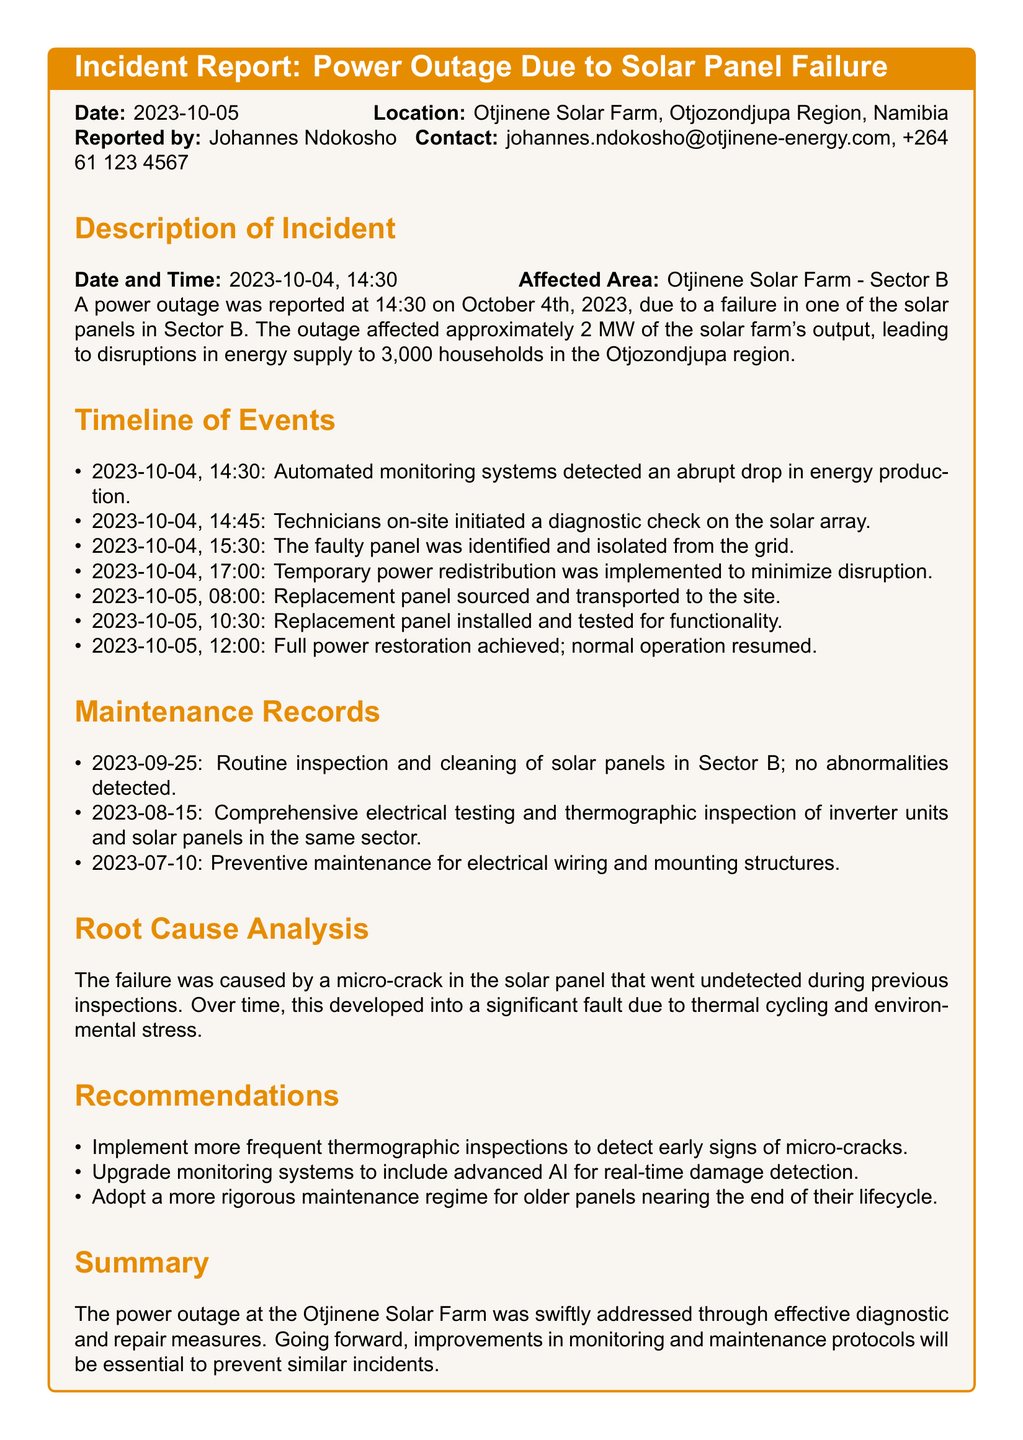what was the date of the incident? The incident occurred on October 4, 2023, as stated in the report.
Answer: October 4, 2023 who reported the incident? The incident report mentions Johannes Ndokosho as the person who reported it.
Answer: Johannes Ndokosho how much power was affected by the outage? The document states that approximately 2 MW of the solar farm's output was affected.
Answer: 2 MW what was the root cause of the solar panel failure? The report describes the root cause as a micro-crack in the solar panel that went undetected.
Answer: micro-crack when was the faulty panel identified? The timeline indicates that the faulty panel was identified on October 4, 2023, at 15:30.
Answer: October 4, 2023, 15:30 what recommendation is given for inspection frequency? The document suggests implementing more frequent thermographic inspections to detect micro-cracks.
Answer: more frequent thermographic inspections how long did it take to restore full power? The timeline states that full power restoration was achieved by October 5, 2023, at 12:00, indicating approximately 21.5 hours for restoration.
Answer: 21.5 hours what maintenance action took place on September 25, 2023? The maintenance record indicates that a routine inspection and cleaning of solar panels occurred on this date without any abnormalities detected.
Answer: routine inspection and cleaning what time was the temporary power redistribution implemented? The list of events mentions that temporary power redistribution was implemented at 17:00 on October 4, 2023.
Answer: 17:00 